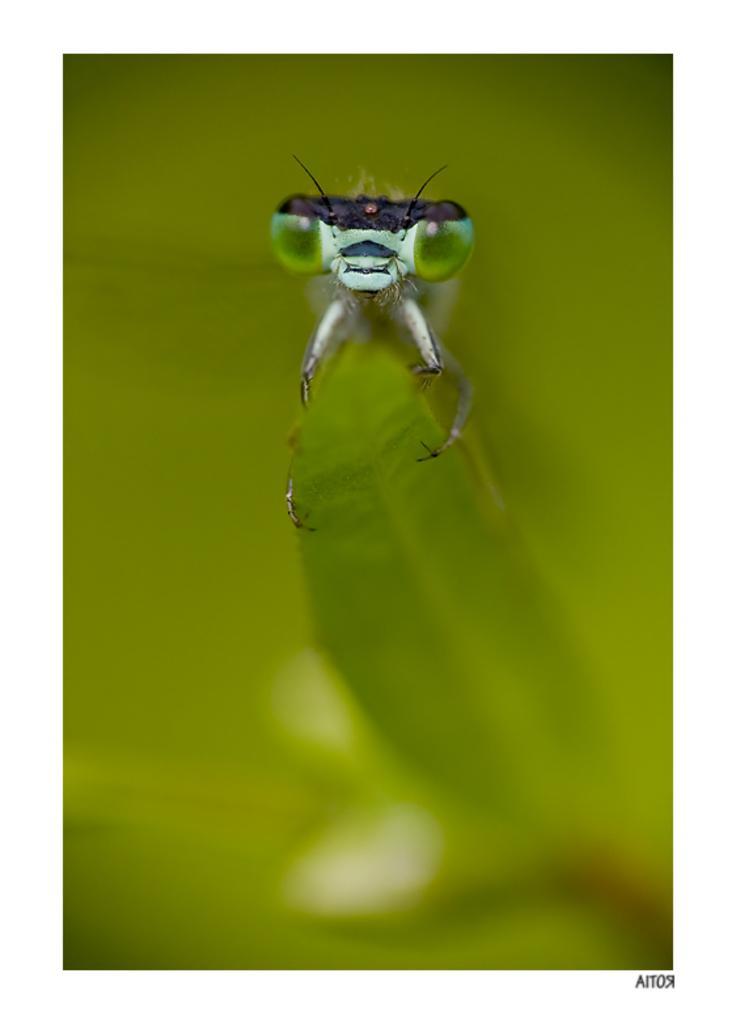In one or two sentences, can you explain what this image depicts? In the picture we can see a insect sitting on the leaf which is green in color and to the insect we can see eyes which are green in color and some legs and antenna and behind the insect we can see green color background. 